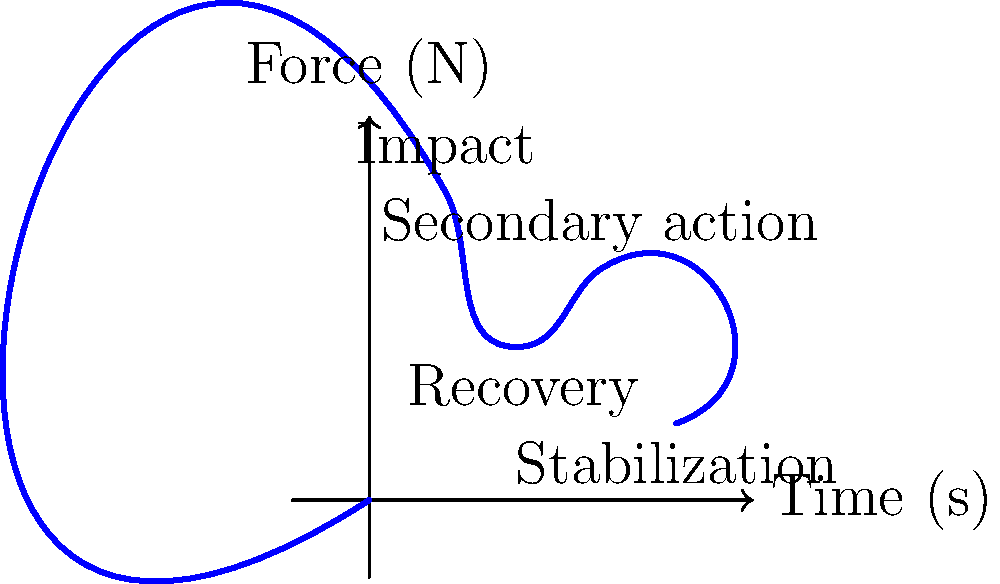In an avant-garde film featuring a complex stunt sequence, the force acting on a performer's body over time is represented by the blue curve. Which phase of the stunt likely involves the highest risk of injury, and why might this be significant from a cinematographic perspective? To answer this question, let's analyze the force curve and its implications:

1. The curve represents the force acting on the stunt performer's body over time.

2. We can identify four distinct phases:
   a) Initial impact (peak at t ≈ 1s)
   b) Recovery (dip at t ≈ 2s)
   c) Secondary action (second peak at t ≈ 3s)
   d) Stabilization (gradual decrease towards t ≈ 4s)

3. The highest point on the curve occurs during the initial impact phase, indicating the largest force experienced by the performer.

4. This peak force during impact presents the highest risk of injury due to:
   - Sudden acceleration or deceleration of body parts
   - Potential for exceeding the body's structural limits

5. From a cinematographic perspective, this high-risk moment is significant because:
   - It creates tension and excitement for the audience
   - It showcases the skill and bravery of the performer
   - It can be used to emphasize the physicality and danger of the scene

6. In avant-garde cinema, this moment of peak force could be:
   - Stylized or exaggerated for artistic effect
   - Used as a metaphor for emotional or psychological impact
   - Manipulated through techniques like slow-motion or rapid cutting to heighten its visual impact

7. The filmmaker must balance the artistic vision with the safety of the performer, which could lead to interesting discussions about the ethics of dangerous stunts in cinema.

Thus, the initial impact phase presents the highest risk of injury and offers significant cinematographic potential for avant-garde filmmaking.
Answer: Initial impact phase; highest force, greatest artistic potential 